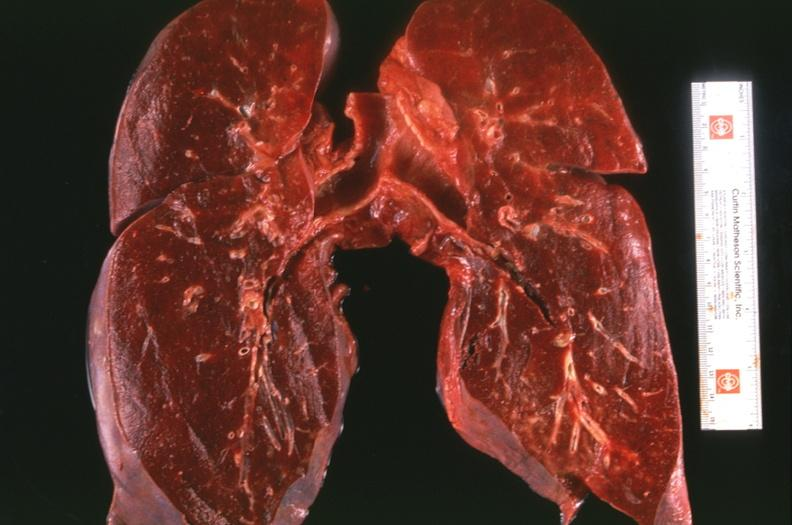what is present?
Answer the question using a single word or phrase. Respiratory 